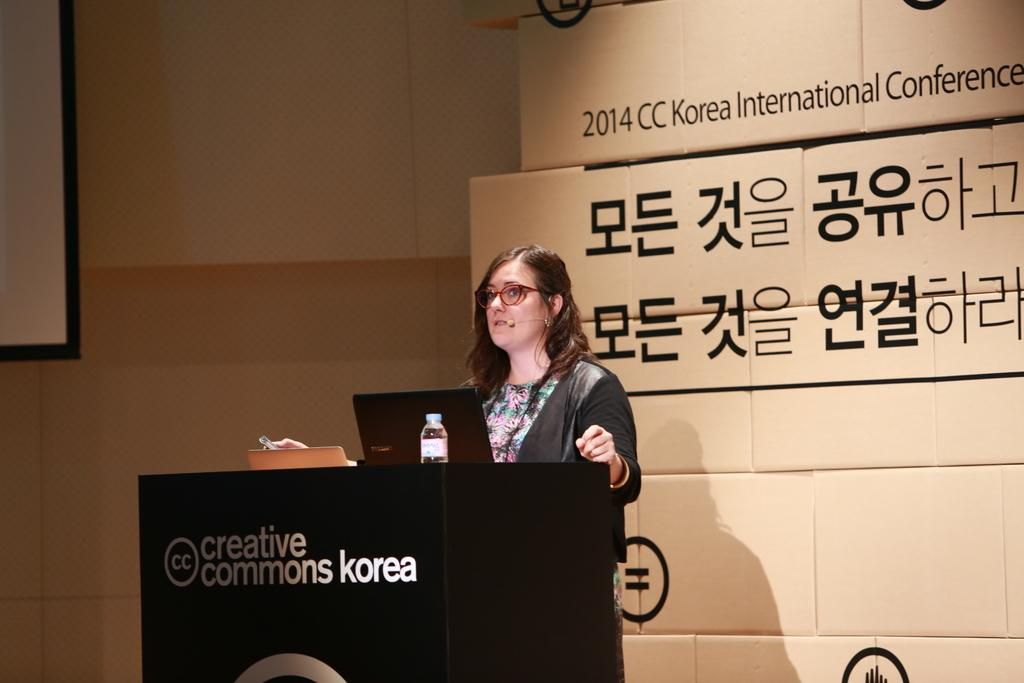What is the main object in the image? There is a podium in the image. Who is present in the image? A woman is standing in the image. What is on the podium? There is a laptop and a water bottle on the podium. What can be seen in the background of the image? There is a wall visible in the image. What color is the kite flying in the image? There is no kite present in the image. What type of silver object can be seen on the podium? There is no silver object present on the podium; only a laptop and a water bottle are visible. 